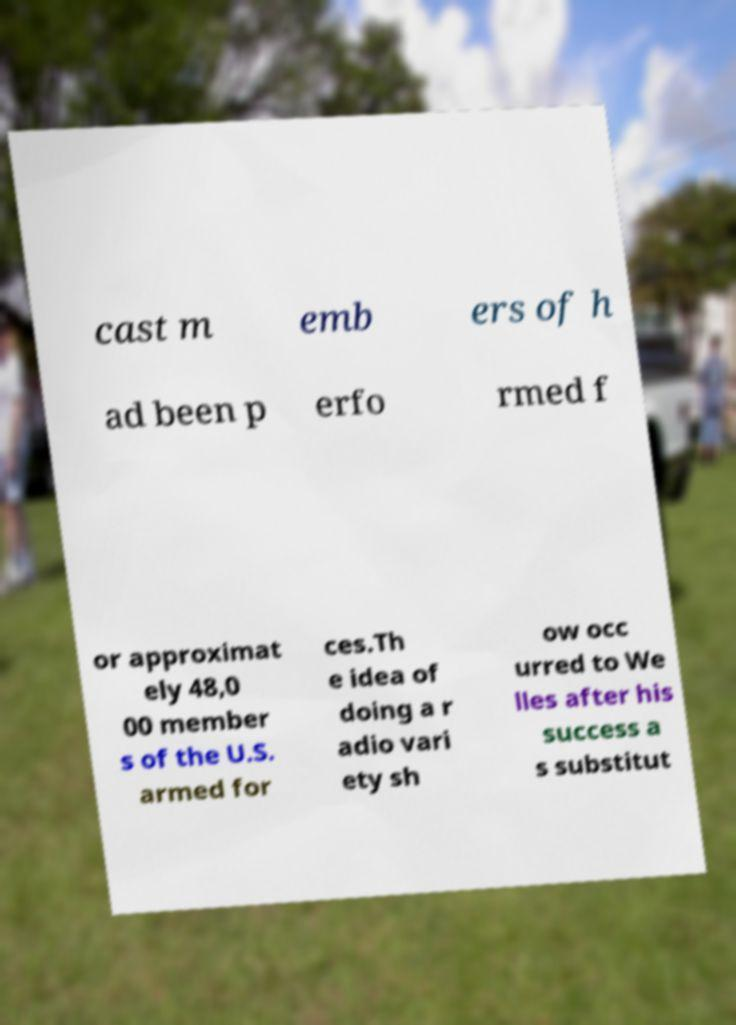There's text embedded in this image that I need extracted. Can you transcribe it verbatim? cast m emb ers of h ad been p erfo rmed f or approximat ely 48,0 00 member s of the U.S. armed for ces.Th e idea of doing a r adio vari ety sh ow occ urred to We lles after his success a s substitut 